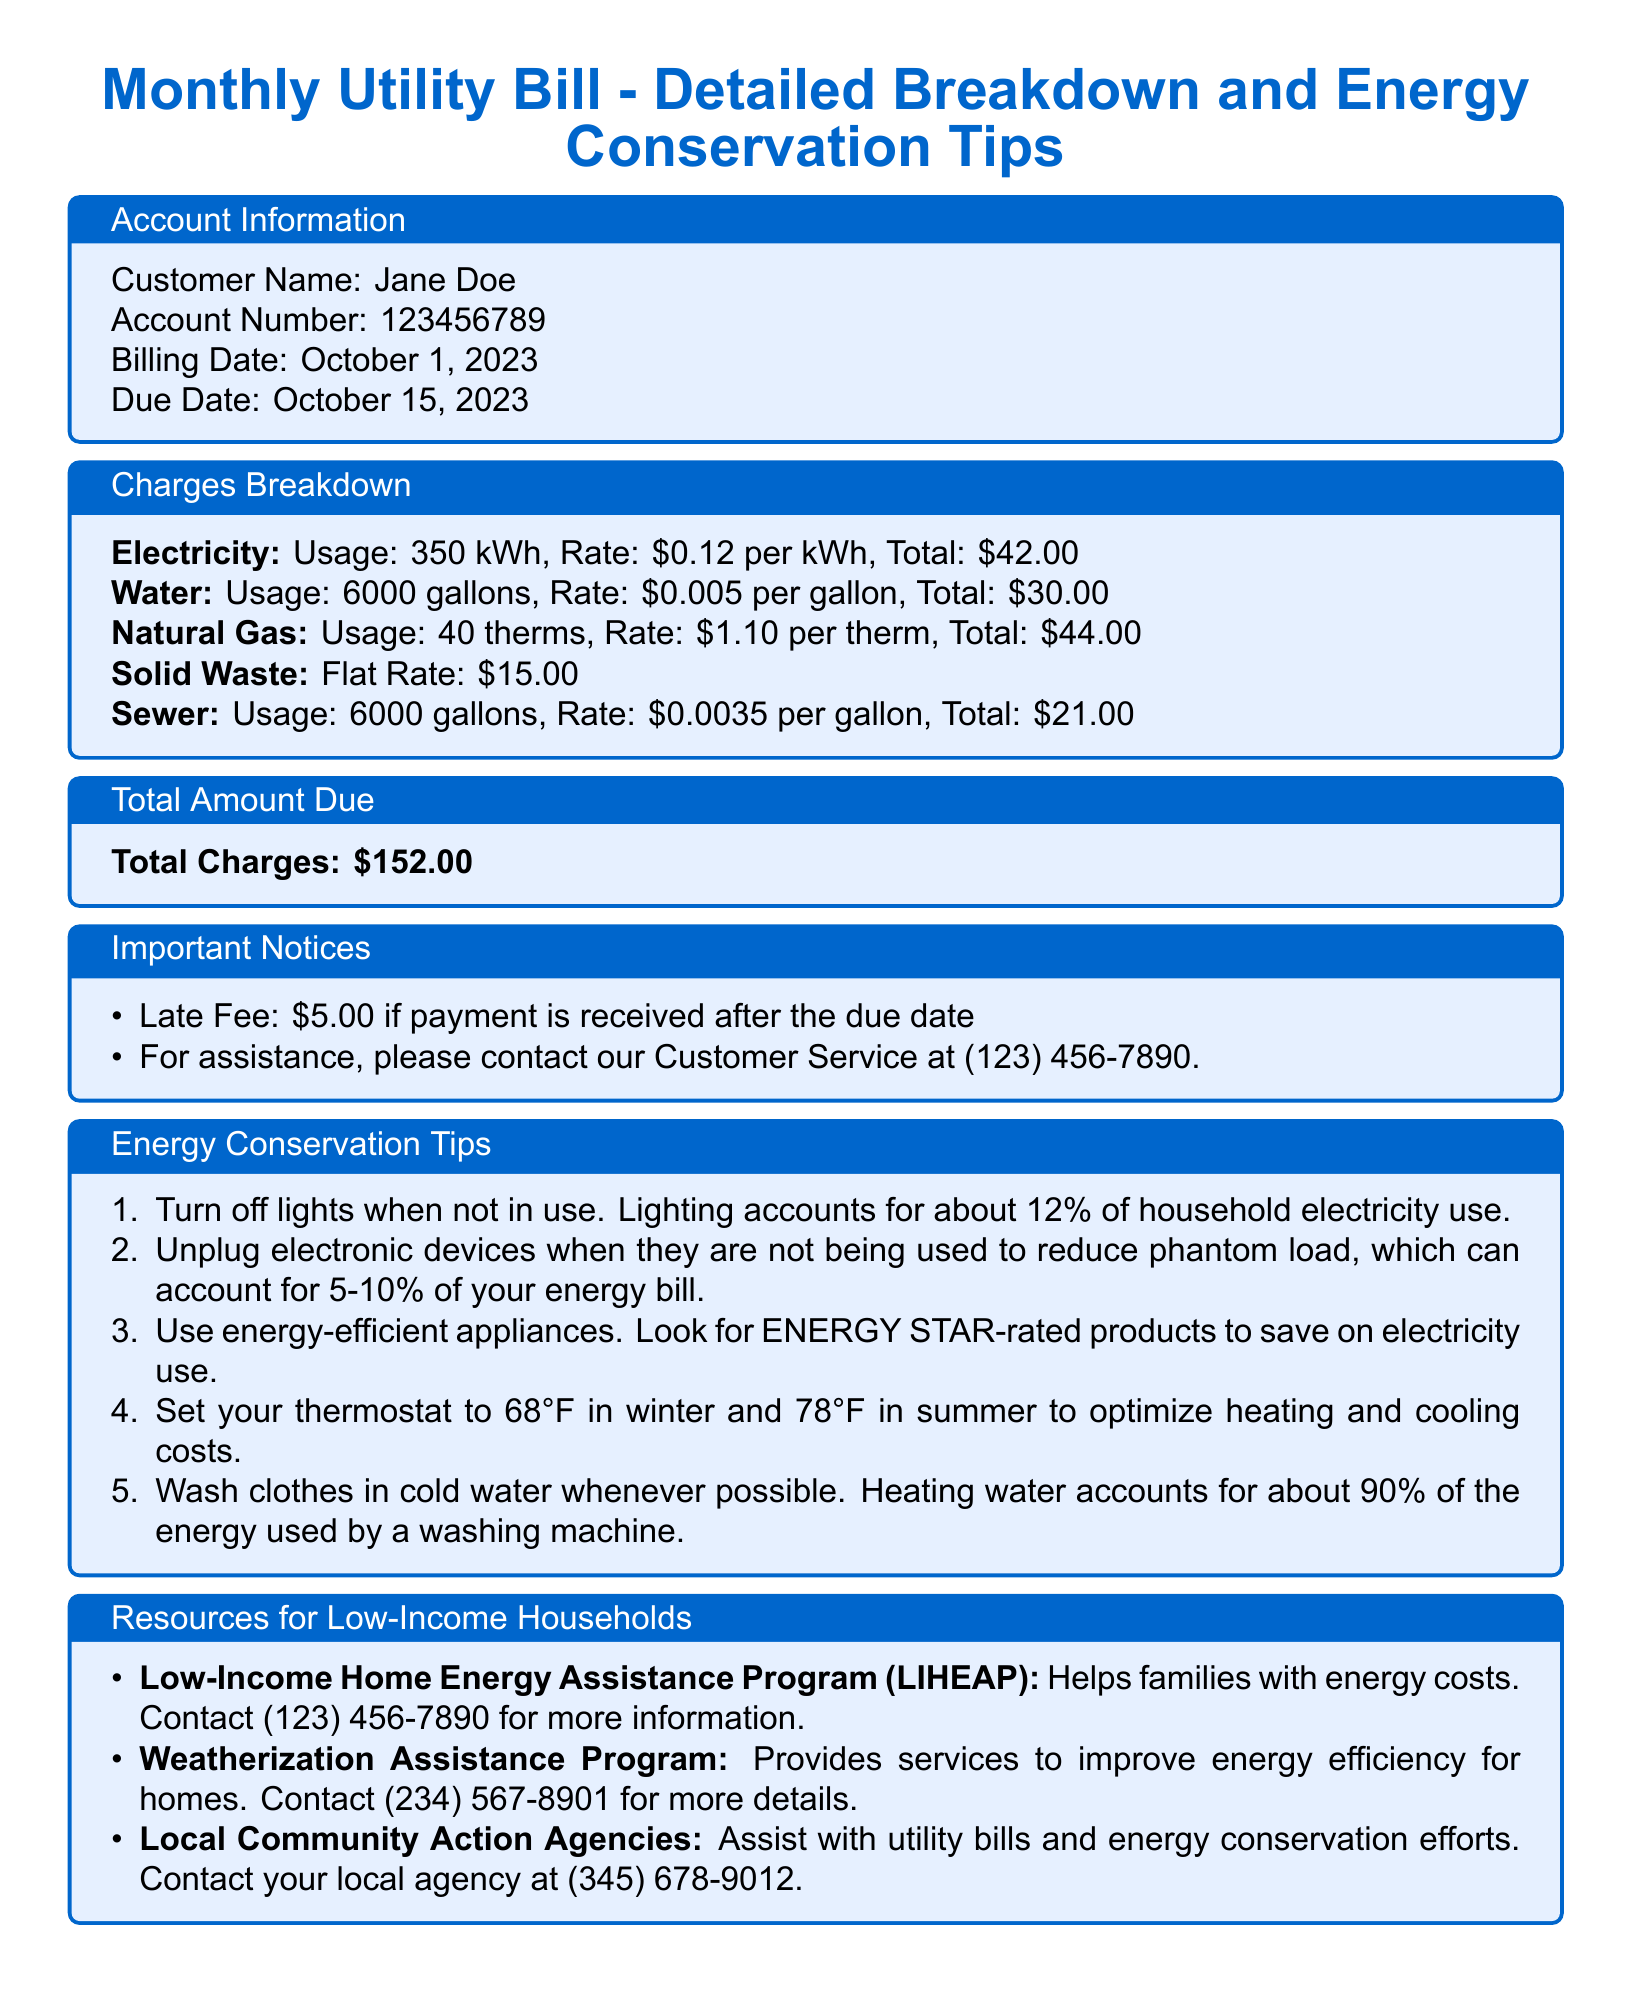What is the customer's name? The customer's name is stated in the account information section of the document.
Answer: Jane Doe What is the total amount due? The total amount due is provided in the charges breakdown section.
Answer: $152.00 When is the billing date? The billing date is mentioned in the account information section of the document.
Answer: October 1, 2023 What is the rate for electricity per kWh? The rate for electricity is found in the charges breakdown section as part of the electricity details.
Answer: $0.12 per kWh How much is the late fee if the payment is received after the due date? The late fee is specified in the important notices section.
Answer: $5.00 How many gallons of water were used? The water usage is detailed in the charges breakdown section of the document.
Answer: 6000 gallons What percentage of household electricity use does lighting account for? The percentage of electricity use accounted for by lighting is given in the energy conservation tips section.
Answer: 12% What program helps families with energy costs? The program assisting families with energy costs is listed under resources for low-income households.
Answer: Low-Income Home Energy Assistance Program (LIHEAP) What is the recommended thermostat setting in summer? The recommended thermostat setting in summer is stated in the energy conservation tips section.
Answer: 78°F 